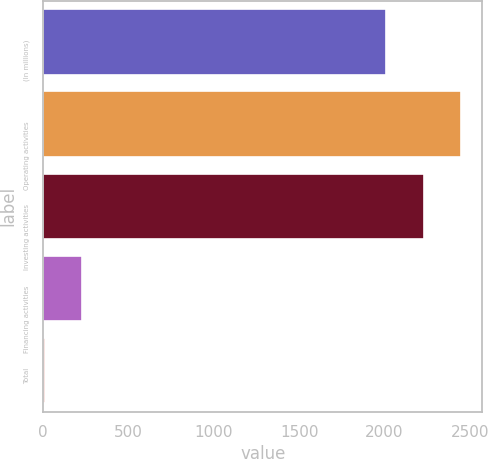Convert chart to OTSL. <chart><loc_0><loc_0><loc_500><loc_500><bar_chart><fcel>(In millions)<fcel>Operating activities<fcel>Investing activities<fcel>Financing activities<fcel>Total<nl><fcel>2010<fcel>2451.4<fcel>2230.7<fcel>230.7<fcel>10<nl></chart> 